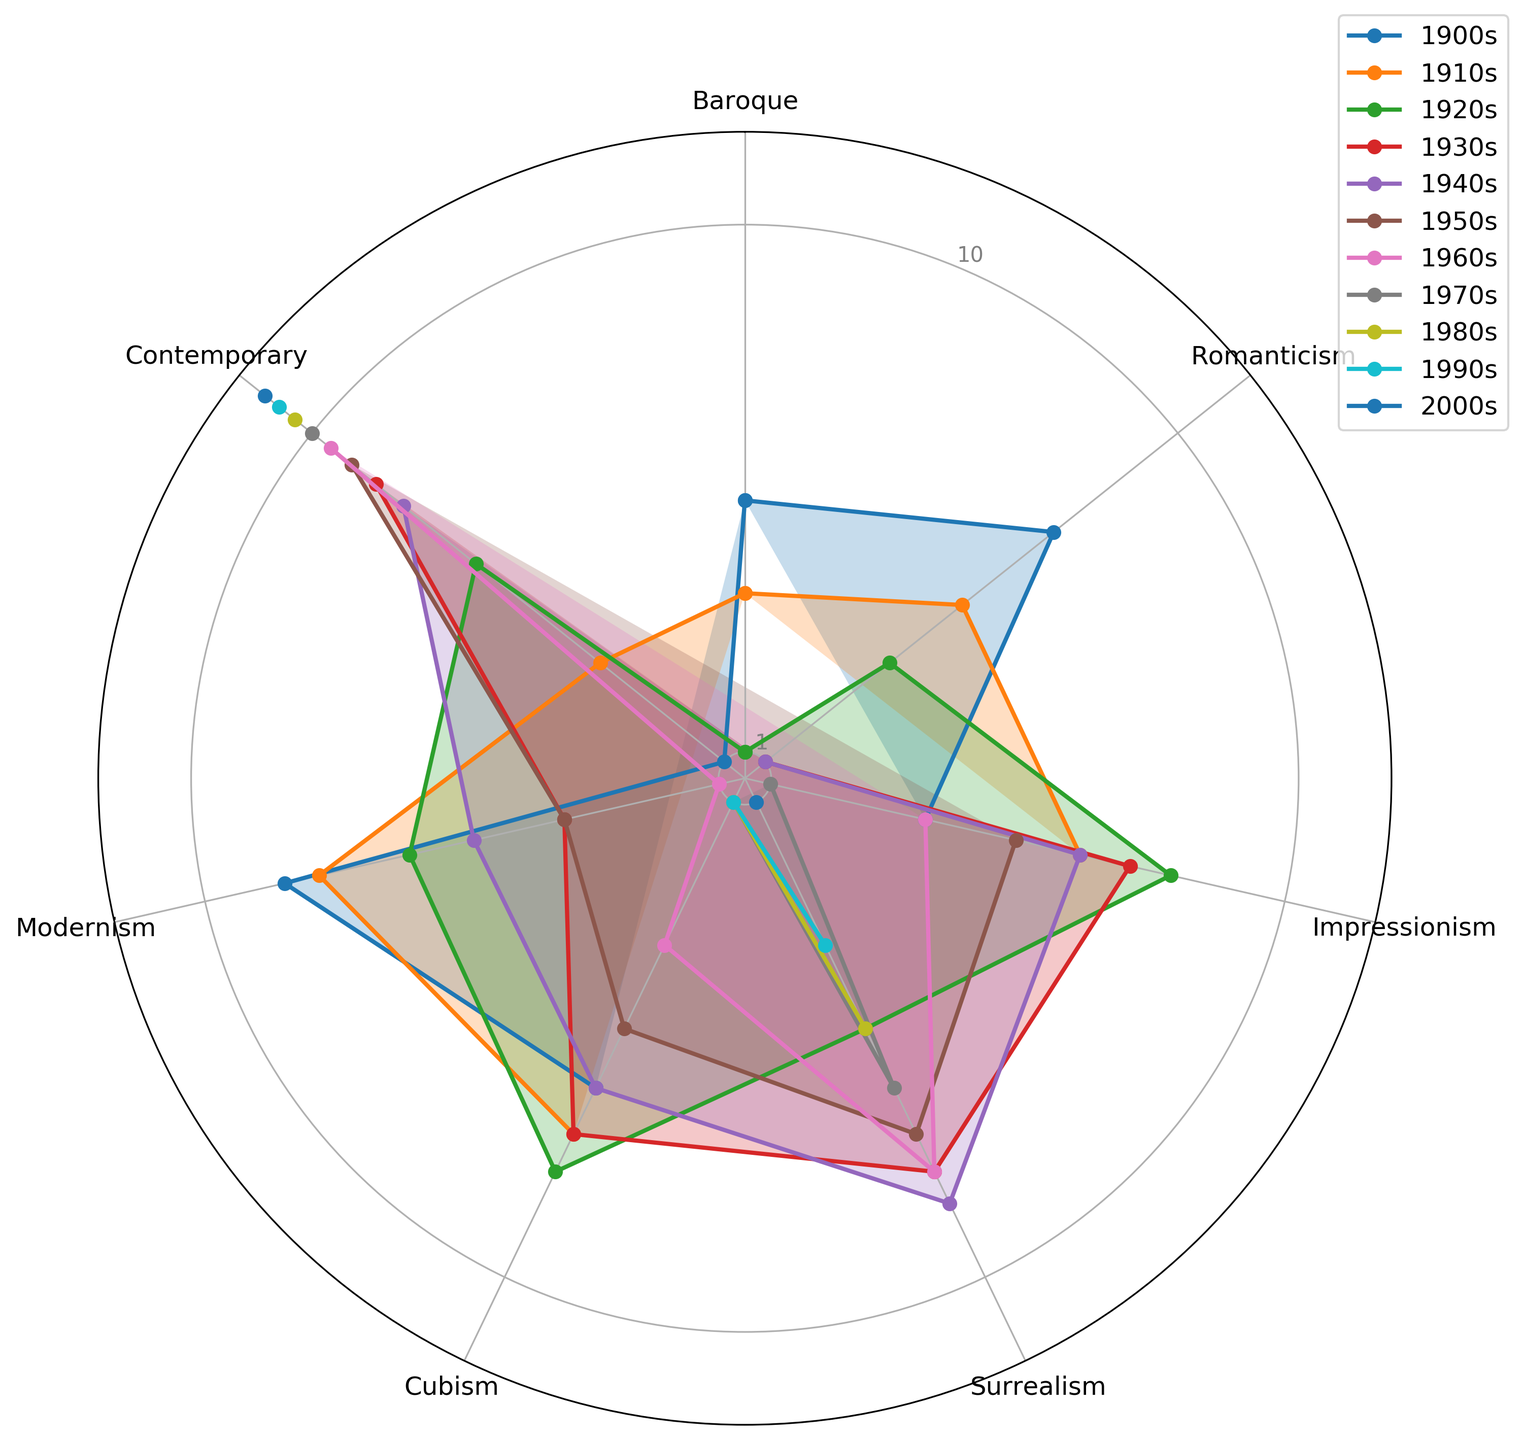What decade has the highest representation of Contemporary art? Look for the line that extends the furthest in the Contemporary section of the radar chart and identify the corresponding decade.
Answer: 2000s How many decades have more Baroque representation than Romanticism representation? Compare the Baroque and Romanticism values for each decade and count the ones where Baroque is higher.
Answer: 2 In which decade did Surrealism first appear and what was its value? Check the radar chart for the Surrealism axis and identify the earliest decade with a non-zero value. Check this value on the chart.
Answer: 1920s, 3 Which art movement has the highest value in the 1970s? Identify the decade 1970s in the radar chart and find which art movement has the longest segment in that decade.
Answer: Contemporary Compare the values of Cubism in the 1920s and 1930s. Which decade has more, and by how much? Look at the length of the Cubism line for the 1920s and 1930s and find the difference between the two values.
Answer: 1930s, 1 What is the sum of the values of Impressionism across all decades? Add the values on the Impressionism axis for each decade to find the total.
Answer: 27 Which decade shows equal representation for Romanticism and Cubism? What is the value? Identify the decades where the lines of Romanticism and Cubism intersect and check the value.
Answer: 1980s, 1 Find the average representation of Modernism in the decades 1900s to 1950s. Sum the Modernism values from 1900s to 1950s and divide by the number of decades (each value between 0-7).
Answer: (7+6+4+2+3+2)/6 = 4 Is there any decade where no art movement has reached a value of 3? If so, name the decade. Check each decade in the radar chart to see if all art movement segments are below 3.
Answer: 2000s 